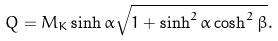<formula> <loc_0><loc_0><loc_500><loc_500>Q = M _ { K } \sinh \alpha \sqrt { 1 + \sinh ^ { 2 } \alpha \cosh ^ { 2 } \beta } .</formula> 